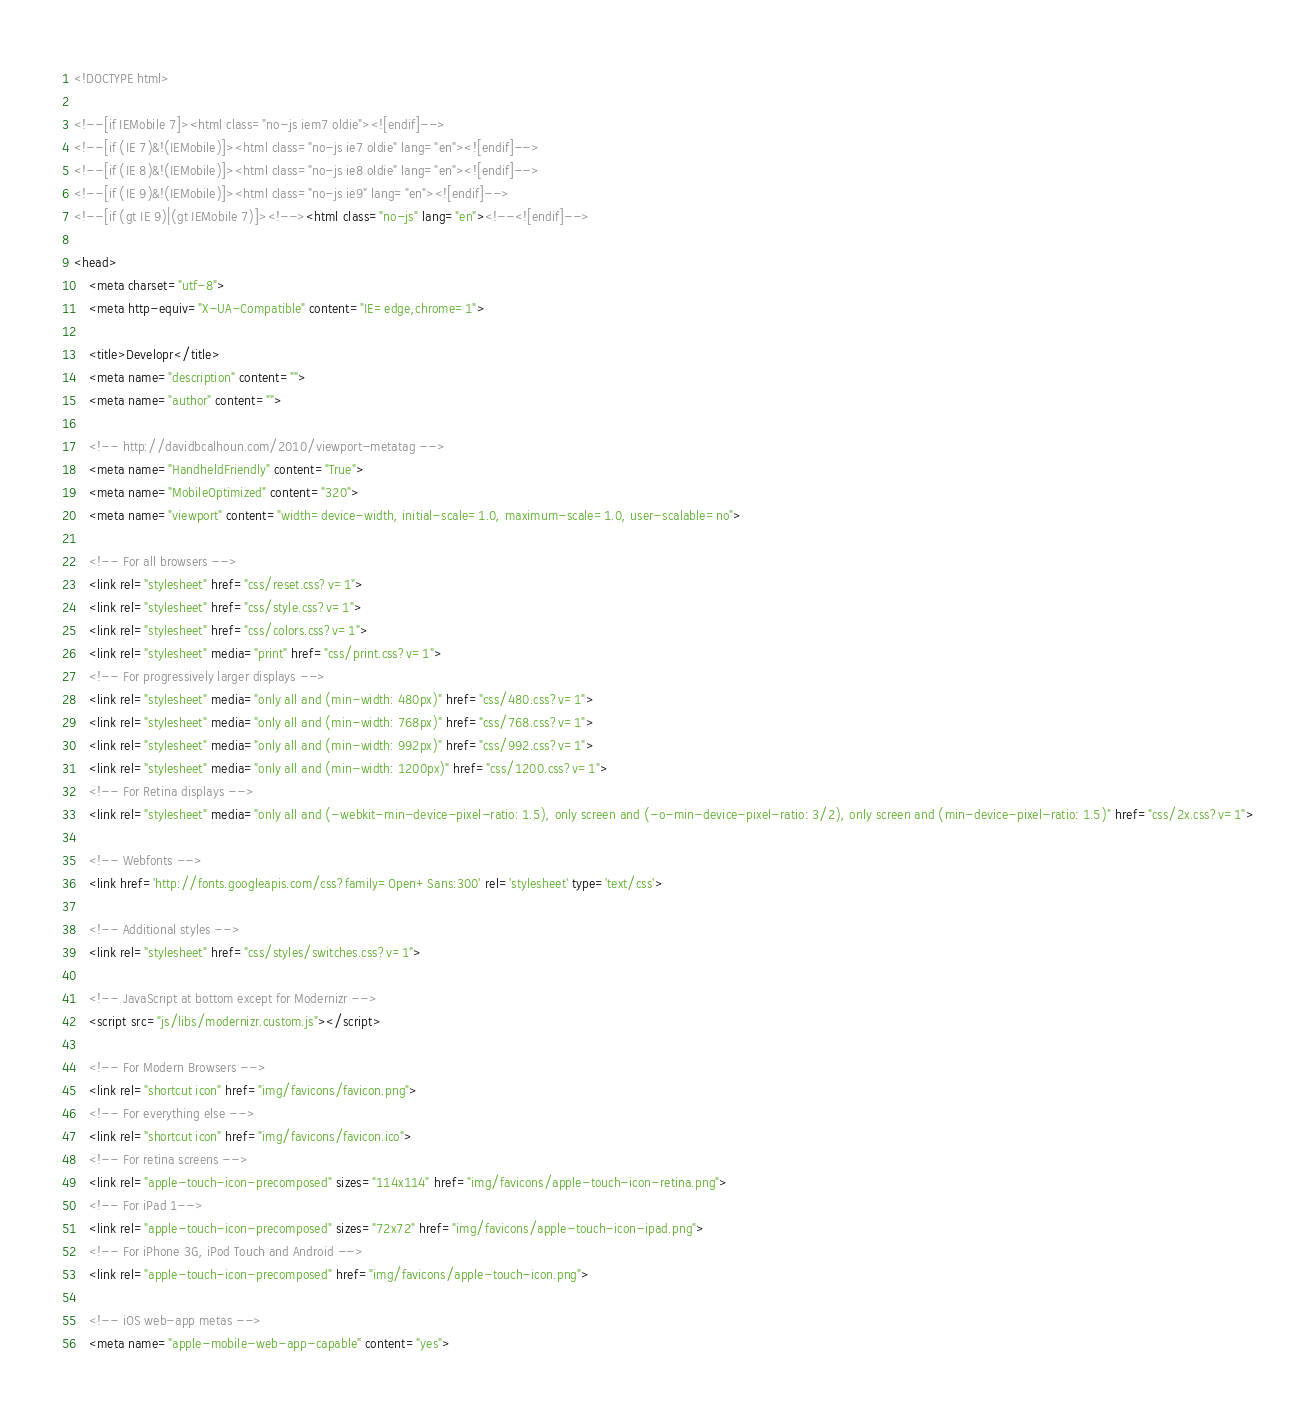<code> <loc_0><loc_0><loc_500><loc_500><_HTML_><!DOCTYPE html>

<!--[if IEMobile 7]><html class="no-js iem7 oldie"><![endif]-->
<!--[if (IE 7)&!(IEMobile)]><html class="no-js ie7 oldie" lang="en"><![endif]-->
<!--[if (IE 8)&!(IEMobile)]><html class="no-js ie8 oldie" lang="en"><![endif]-->
<!--[if (IE 9)&!(IEMobile)]><html class="no-js ie9" lang="en"><![endif]-->
<!--[if (gt IE 9)|(gt IEMobile 7)]><!--><html class="no-js" lang="en"><!--<![endif]-->

<head>
	<meta charset="utf-8">
	<meta http-equiv="X-UA-Compatible" content="IE=edge,chrome=1">

	<title>Developr</title>
	<meta name="description" content="">
	<meta name="author" content="">

	<!-- http://davidbcalhoun.com/2010/viewport-metatag -->
	<meta name="HandheldFriendly" content="True">
	<meta name="MobileOptimized" content="320">
	<meta name="viewport" content="width=device-width, initial-scale=1.0, maximum-scale=1.0, user-scalable=no">

	<!-- For all browsers -->
	<link rel="stylesheet" href="css/reset.css?v=1">
	<link rel="stylesheet" href="css/style.css?v=1">
	<link rel="stylesheet" href="css/colors.css?v=1">
	<link rel="stylesheet" media="print" href="css/print.css?v=1">
	<!-- For progressively larger displays -->
	<link rel="stylesheet" media="only all and (min-width: 480px)" href="css/480.css?v=1">
	<link rel="stylesheet" media="only all and (min-width: 768px)" href="css/768.css?v=1">
	<link rel="stylesheet" media="only all and (min-width: 992px)" href="css/992.css?v=1">
	<link rel="stylesheet" media="only all and (min-width: 1200px)" href="css/1200.css?v=1">
	<!-- For Retina displays -->
	<link rel="stylesheet" media="only all and (-webkit-min-device-pixel-ratio: 1.5), only screen and (-o-min-device-pixel-ratio: 3/2), only screen and (min-device-pixel-ratio: 1.5)" href="css/2x.css?v=1">

	<!-- Webfonts -->
	<link href='http://fonts.googleapis.com/css?family=Open+Sans:300' rel='stylesheet' type='text/css'>

	<!-- Additional styles -->
	<link rel="stylesheet" href="css/styles/switches.css?v=1">

	<!-- JavaScript at bottom except for Modernizr -->
	<script src="js/libs/modernizr.custom.js"></script>

	<!-- For Modern Browsers -->
	<link rel="shortcut icon" href="img/favicons/favicon.png">
	<!-- For everything else -->
	<link rel="shortcut icon" href="img/favicons/favicon.ico">
	<!-- For retina screens -->
	<link rel="apple-touch-icon-precomposed" sizes="114x114" href="img/favicons/apple-touch-icon-retina.png">
	<!-- For iPad 1-->
	<link rel="apple-touch-icon-precomposed" sizes="72x72" href="img/favicons/apple-touch-icon-ipad.png">
	<!-- For iPhone 3G, iPod Touch and Android -->
	<link rel="apple-touch-icon-precomposed" href="img/favicons/apple-touch-icon.png">

	<!-- iOS web-app metas -->
	<meta name="apple-mobile-web-app-capable" content="yes"></code> 